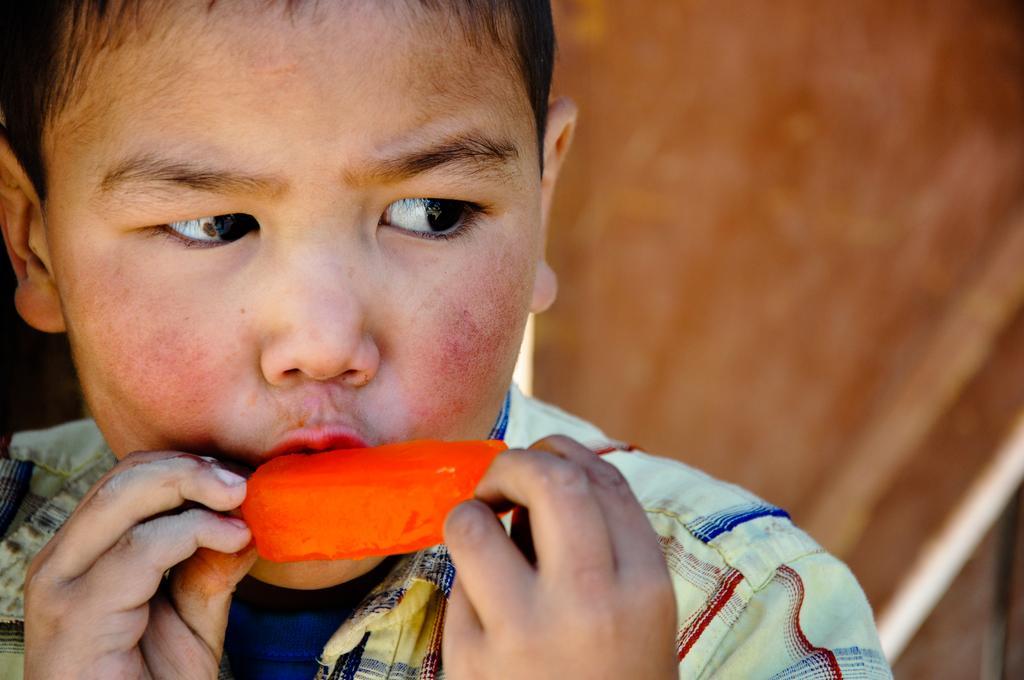Can you describe this image briefly? In this image we can see a person. A person is eating a ice cream. 